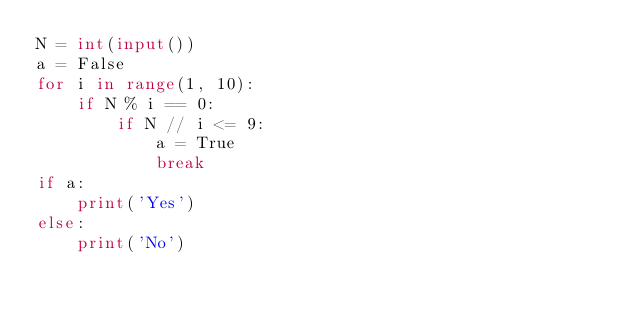Convert code to text. <code><loc_0><loc_0><loc_500><loc_500><_Python_>N = int(input())
a = False
for i in range(1, 10):
	if N % i == 0:
		if N // i <= 9:
			a = True
			break
if a:
	print('Yes')
else:
	print('No')

</code> 